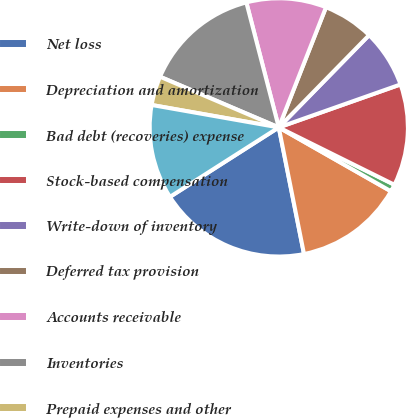Convert chart to OTSL. <chart><loc_0><loc_0><loc_500><loc_500><pie_chart><fcel>Net loss<fcel>Depreciation and amortization<fcel>Bad debt (recoveries) expense<fcel>Stock-based compensation<fcel>Write-down of inventory<fcel>Deferred tax provision<fcel>Accounts receivable<fcel>Inventories<fcel>Prepaid expenses and other<fcel>Accounts payable<nl><fcel>19.09%<fcel>13.63%<fcel>0.91%<fcel>12.73%<fcel>7.27%<fcel>6.37%<fcel>10.0%<fcel>14.54%<fcel>3.64%<fcel>11.82%<nl></chart> 